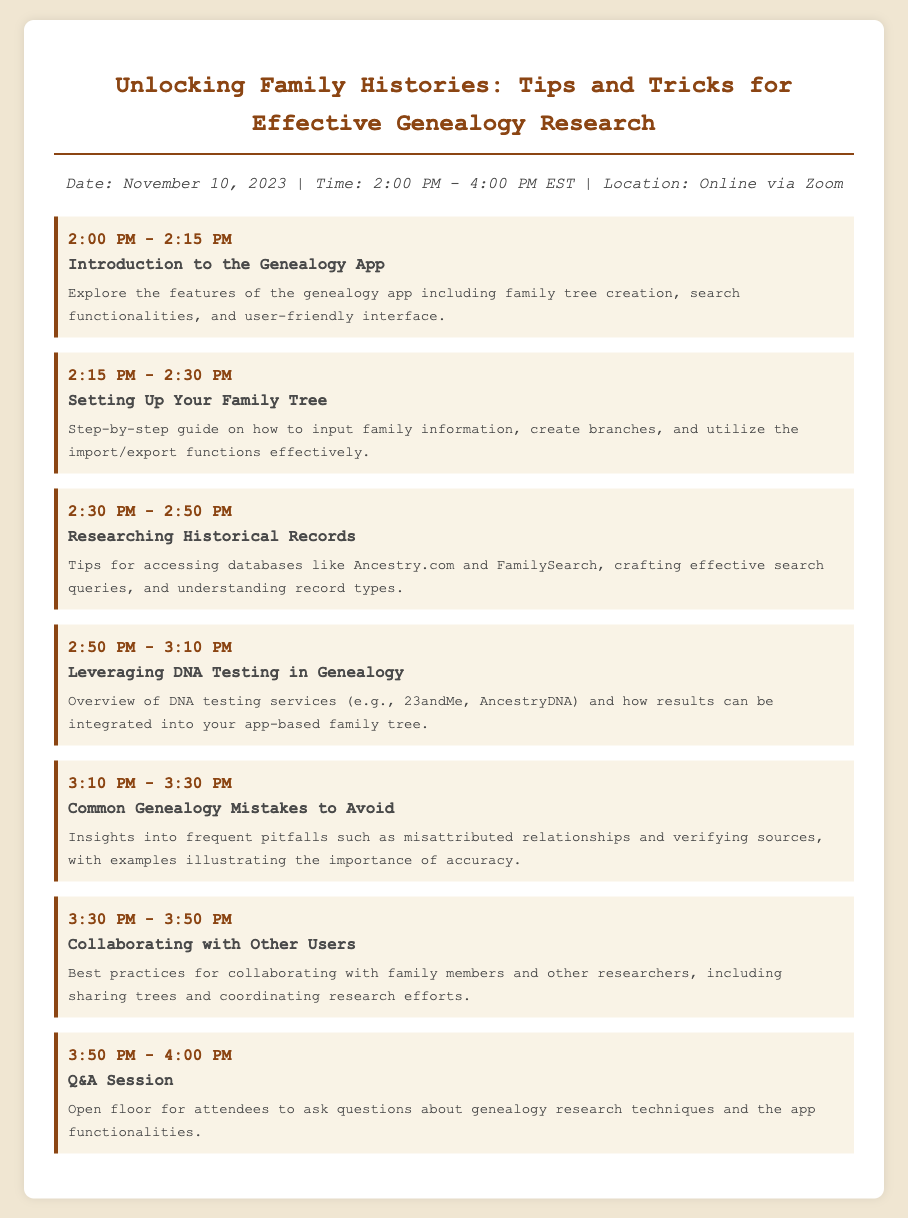What is the date of the webinar? The date of the webinar is mentioned in the document as November 10, 2023.
Answer: November 10, 2023 What is the time duration of the webinar? The time duration can be calculated from 2:00 PM to 4:00 PM, which indicates it lasts for 2 hours.
Answer: 2 hours What is the first agenda topic? The first agenda topic listed in the document is "Introduction to the Genealogy App."
Answer: Introduction to the Genealogy App What is the focus of the second agenda item? The second agenda item explains how to set up a family tree in the app, guiding users on inputting information.
Answer: Setting Up Your Family Tree What time does the Q&A session start? The Q&A session is scheduled from 3:50 PM to 4:00 PM, hence it starts at 3:50 PM.
Answer: 3:50 PM What is covered in the topic on DNA testing? The topic on DNA testing provides an overview of DNA testing services and their integration into the family tree.
Answer: Overview of DNA Testing Services How many items are there in the agenda? The document lists seven distinct agenda items covering various topics.
Answer: Seven What type of mistakes does the webinar address? The webinar discusses common genealogy mistakes such as misattributed relationships.
Answer: Common Genealogy Mistakes What is the platform for the webinar? The platform mentioned for conducting the webinar is Zoom, as stated in the document.
Answer: Zoom 